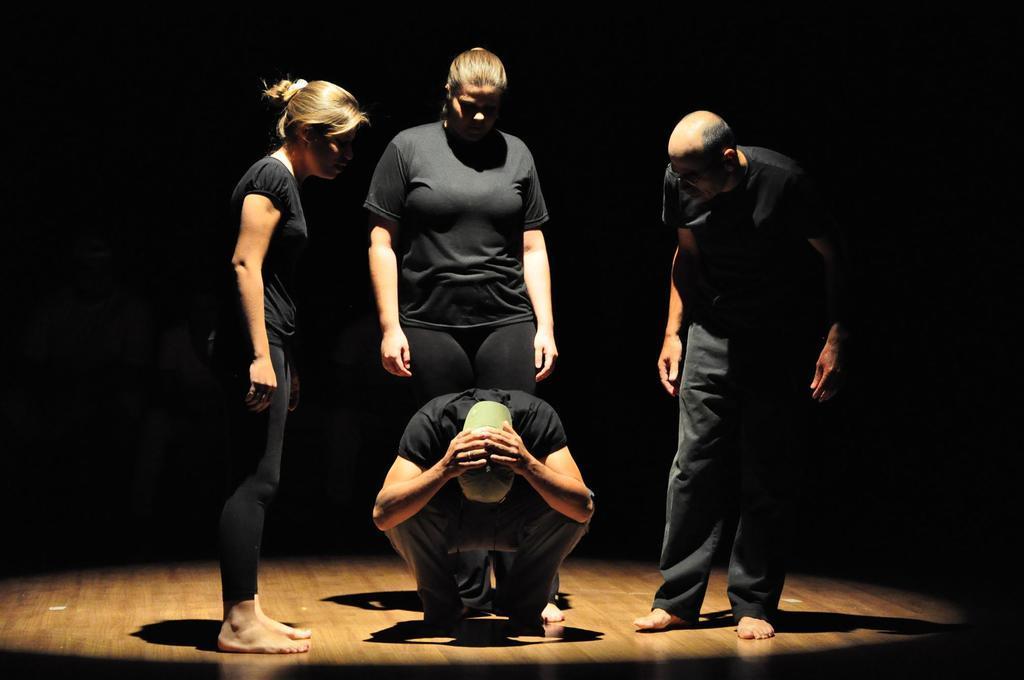Can you describe this image briefly? There are four people on a platform. Person in the center is wearing a cap. In the background it is dark. 